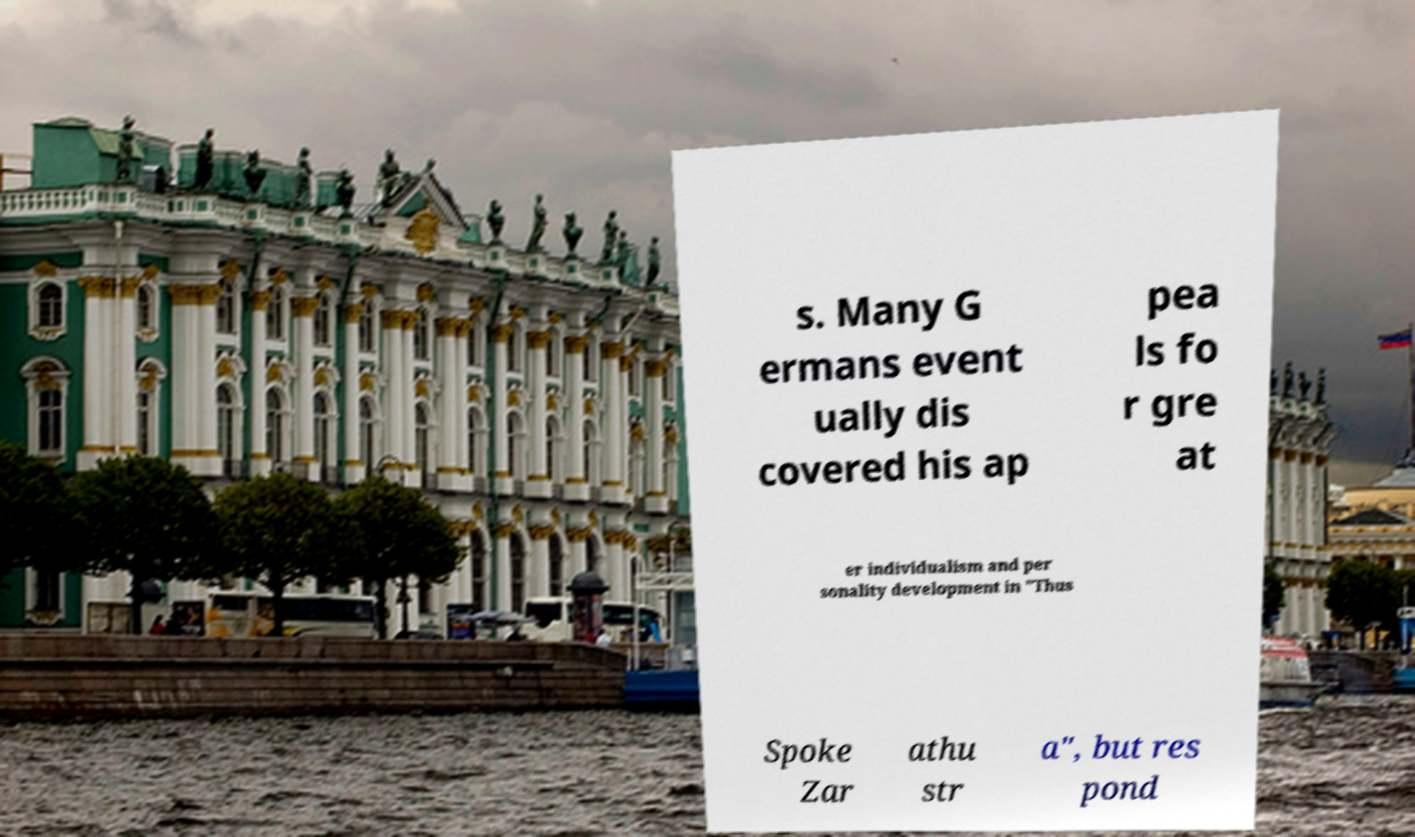I need the written content from this picture converted into text. Can you do that? s. Many G ermans event ually dis covered his ap pea ls fo r gre at er individualism and per sonality development in "Thus Spoke Zar athu str a", but res pond 